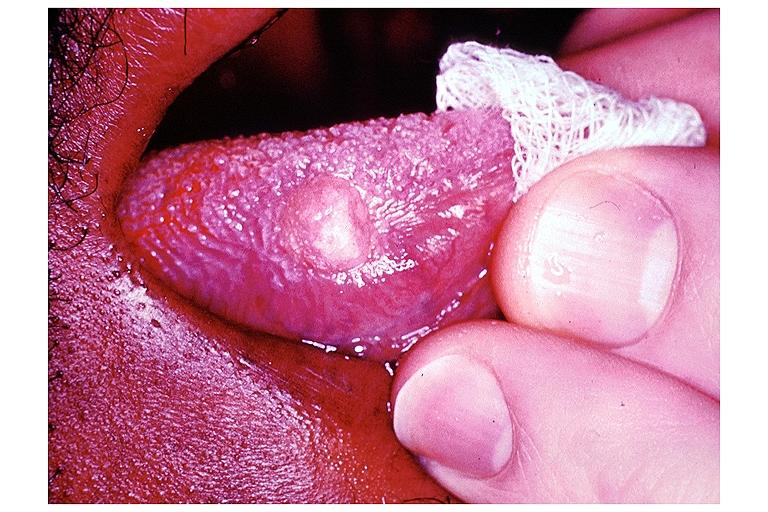s oral present?
Answer the question using a single word or phrase. Yes 